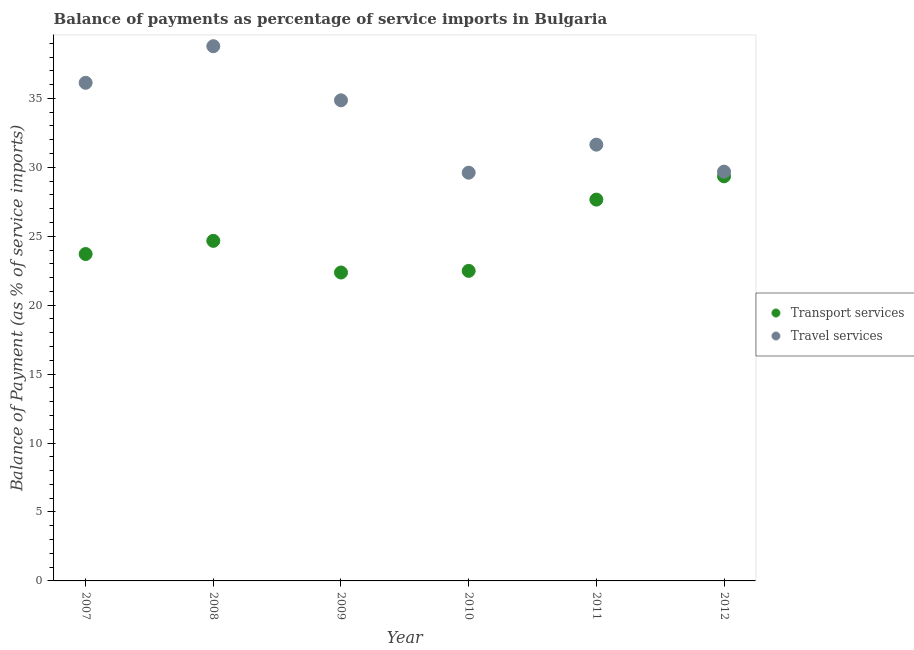How many different coloured dotlines are there?
Your response must be concise. 2. What is the balance of payments of transport services in 2007?
Provide a short and direct response. 23.71. Across all years, what is the maximum balance of payments of transport services?
Provide a short and direct response. 29.35. Across all years, what is the minimum balance of payments of transport services?
Your answer should be very brief. 22.37. What is the total balance of payments of travel services in the graph?
Offer a terse response. 200.73. What is the difference between the balance of payments of travel services in 2007 and that in 2012?
Give a very brief answer. 6.44. What is the difference between the balance of payments of travel services in 2007 and the balance of payments of transport services in 2010?
Give a very brief answer. 13.64. What is the average balance of payments of travel services per year?
Your answer should be compact. 33.45. In the year 2009, what is the difference between the balance of payments of travel services and balance of payments of transport services?
Offer a terse response. 12.49. What is the ratio of the balance of payments of travel services in 2007 to that in 2011?
Your answer should be compact. 1.14. Is the difference between the balance of payments of travel services in 2011 and 2012 greater than the difference between the balance of payments of transport services in 2011 and 2012?
Offer a terse response. Yes. What is the difference between the highest and the second highest balance of payments of transport services?
Your answer should be very brief. 1.69. What is the difference between the highest and the lowest balance of payments of travel services?
Your answer should be compact. 9.18. In how many years, is the balance of payments of transport services greater than the average balance of payments of transport services taken over all years?
Offer a terse response. 2. Does the balance of payments of transport services monotonically increase over the years?
Give a very brief answer. No. Is the balance of payments of travel services strictly greater than the balance of payments of transport services over the years?
Keep it short and to the point. Yes. What is the difference between two consecutive major ticks on the Y-axis?
Keep it short and to the point. 5. Are the values on the major ticks of Y-axis written in scientific E-notation?
Provide a short and direct response. No. Does the graph contain any zero values?
Your answer should be compact. No. Where does the legend appear in the graph?
Make the answer very short. Center right. What is the title of the graph?
Provide a short and direct response. Balance of payments as percentage of service imports in Bulgaria. Does "Female entrants" appear as one of the legend labels in the graph?
Your response must be concise. No. What is the label or title of the X-axis?
Make the answer very short. Year. What is the label or title of the Y-axis?
Ensure brevity in your answer.  Balance of Payment (as % of service imports). What is the Balance of Payment (as % of service imports) in Transport services in 2007?
Provide a succinct answer. 23.71. What is the Balance of Payment (as % of service imports) in Travel services in 2007?
Offer a terse response. 36.13. What is the Balance of Payment (as % of service imports) in Transport services in 2008?
Keep it short and to the point. 24.67. What is the Balance of Payment (as % of service imports) of Travel services in 2008?
Your response must be concise. 38.79. What is the Balance of Payment (as % of service imports) in Transport services in 2009?
Provide a succinct answer. 22.37. What is the Balance of Payment (as % of service imports) in Travel services in 2009?
Ensure brevity in your answer.  34.86. What is the Balance of Payment (as % of service imports) of Transport services in 2010?
Provide a succinct answer. 22.49. What is the Balance of Payment (as % of service imports) of Travel services in 2010?
Offer a terse response. 29.61. What is the Balance of Payment (as % of service imports) in Transport services in 2011?
Make the answer very short. 27.66. What is the Balance of Payment (as % of service imports) in Travel services in 2011?
Keep it short and to the point. 31.65. What is the Balance of Payment (as % of service imports) in Transport services in 2012?
Keep it short and to the point. 29.35. What is the Balance of Payment (as % of service imports) of Travel services in 2012?
Offer a terse response. 29.69. Across all years, what is the maximum Balance of Payment (as % of service imports) in Transport services?
Your answer should be very brief. 29.35. Across all years, what is the maximum Balance of Payment (as % of service imports) of Travel services?
Offer a terse response. 38.79. Across all years, what is the minimum Balance of Payment (as % of service imports) in Transport services?
Your response must be concise. 22.37. Across all years, what is the minimum Balance of Payment (as % of service imports) in Travel services?
Provide a succinct answer. 29.61. What is the total Balance of Payment (as % of service imports) of Transport services in the graph?
Give a very brief answer. 150.25. What is the total Balance of Payment (as % of service imports) of Travel services in the graph?
Offer a terse response. 200.73. What is the difference between the Balance of Payment (as % of service imports) of Transport services in 2007 and that in 2008?
Offer a very short reply. -0.96. What is the difference between the Balance of Payment (as % of service imports) in Travel services in 2007 and that in 2008?
Ensure brevity in your answer.  -2.66. What is the difference between the Balance of Payment (as % of service imports) of Transport services in 2007 and that in 2009?
Make the answer very short. 1.34. What is the difference between the Balance of Payment (as % of service imports) of Travel services in 2007 and that in 2009?
Your response must be concise. 1.27. What is the difference between the Balance of Payment (as % of service imports) of Transport services in 2007 and that in 2010?
Keep it short and to the point. 1.22. What is the difference between the Balance of Payment (as % of service imports) in Travel services in 2007 and that in 2010?
Provide a short and direct response. 6.52. What is the difference between the Balance of Payment (as % of service imports) of Transport services in 2007 and that in 2011?
Your response must be concise. -3.95. What is the difference between the Balance of Payment (as % of service imports) of Travel services in 2007 and that in 2011?
Provide a short and direct response. 4.49. What is the difference between the Balance of Payment (as % of service imports) in Transport services in 2007 and that in 2012?
Ensure brevity in your answer.  -5.64. What is the difference between the Balance of Payment (as % of service imports) of Travel services in 2007 and that in 2012?
Your answer should be compact. 6.44. What is the difference between the Balance of Payment (as % of service imports) of Transport services in 2008 and that in 2009?
Your answer should be very brief. 2.3. What is the difference between the Balance of Payment (as % of service imports) in Travel services in 2008 and that in 2009?
Make the answer very short. 3.93. What is the difference between the Balance of Payment (as % of service imports) of Transport services in 2008 and that in 2010?
Offer a very short reply. 2.18. What is the difference between the Balance of Payment (as % of service imports) of Travel services in 2008 and that in 2010?
Keep it short and to the point. 9.18. What is the difference between the Balance of Payment (as % of service imports) in Transport services in 2008 and that in 2011?
Offer a terse response. -2.99. What is the difference between the Balance of Payment (as % of service imports) in Travel services in 2008 and that in 2011?
Your response must be concise. 7.14. What is the difference between the Balance of Payment (as % of service imports) in Transport services in 2008 and that in 2012?
Provide a succinct answer. -4.68. What is the difference between the Balance of Payment (as % of service imports) of Travel services in 2008 and that in 2012?
Give a very brief answer. 9.1. What is the difference between the Balance of Payment (as % of service imports) of Transport services in 2009 and that in 2010?
Ensure brevity in your answer.  -0.12. What is the difference between the Balance of Payment (as % of service imports) in Travel services in 2009 and that in 2010?
Keep it short and to the point. 5.25. What is the difference between the Balance of Payment (as % of service imports) of Transport services in 2009 and that in 2011?
Make the answer very short. -5.29. What is the difference between the Balance of Payment (as % of service imports) in Travel services in 2009 and that in 2011?
Your answer should be very brief. 3.22. What is the difference between the Balance of Payment (as % of service imports) of Transport services in 2009 and that in 2012?
Provide a succinct answer. -6.98. What is the difference between the Balance of Payment (as % of service imports) of Travel services in 2009 and that in 2012?
Your answer should be very brief. 5.17. What is the difference between the Balance of Payment (as % of service imports) in Transport services in 2010 and that in 2011?
Your answer should be compact. -5.17. What is the difference between the Balance of Payment (as % of service imports) in Travel services in 2010 and that in 2011?
Provide a succinct answer. -2.03. What is the difference between the Balance of Payment (as % of service imports) of Transport services in 2010 and that in 2012?
Offer a very short reply. -6.86. What is the difference between the Balance of Payment (as % of service imports) of Travel services in 2010 and that in 2012?
Keep it short and to the point. -0.08. What is the difference between the Balance of Payment (as % of service imports) in Transport services in 2011 and that in 2012?
Keep it short and to the point. -1.69. What is the difference between the Balance of Payment (as % of service imports) of Travel services in 2011 and that in 2012?
Provide a succinct answer. 1.96. What is the difference between the Balance of Payment (as % of service imports) in Transport services in 2007 and the Balance of Payment (as % of service imports) in Travel services in 2008?
Provide a short and direct response. -15.08. What is the difference between the Balance of Payment (as % of service imports) in Transport services in 2007 and the Balance of Payment (as % of service imports) in Travel services in 2009?
Give a very brief answer. -11.15. What is the difference between the Balance of Payment (as % of service imports) in Transport services in 2007 and the Balance of Payment (as % of service imports) in Travel services in 2010?
Offer a terse response. -5.9. What is the difference between the Balance of Payment (as % of service imports) in Transport services in 2007 and the Balance of Payment (as % of service imports) in Travel services in 2011?
Offer a terse response. -7.93. What is the difference between the Balance of Payment (as % of service imports) of Transport services in 2007 and the Balance of Payment (as % of service imports) of Travel services in 2012?
Provide a succinct answer. -5.98. What is the difference between the Balance of Payment (as % of service imports) in Transport services in 2008 and the Balance of Payment (as % of service imports) in Travel services in 2009?
Keep it short and to the point. -10.19. What is the difference between the Balance of Payment (as % of service imports) of Transport services in 2008 and the Balance of Payment (as % of service imports) of Travel services in 2010?
Give a very brief answer. -4.94. What is the difference between the Balance of Payment (as % of service imports) of Transport services in 2008 and the Balance of Payment (as % of service imports) of Travel services in 2011?
Ensure brevity in your answer.  -6.98. What is the difference between the Balance of Payment (as % of service imports) of Transport services in 2008 and the Balance of Payment (as % of service imports) of Travel services in 2012?
Provide a succinct answer. -5.02. What is the difference between the Balance of Payment (as % of service imports) of Transport services in 2009 and the Balance of Payment (as % of service imports) of Travel services in 2010?
Your response must be concise. -7.24. What is the difference between the Balance of Payment (as % of service imports) in Transport services in 2009 and the Balance of Payment (as % of service imports) in Travel services in 2011?
Provide a short and direct response. -9.27. What is the difference between the Balance of Payment (as % of service imports) of Transport services in 2009 and the Balance of Payment (as % of service imports) of Travel services in 2012?
Ensure brevity in your answer.  -7.32. What is the difference between the Balance of Payment (as % of service imports) of Transport services in 2010 and the Balance of Payment (as % of service imports) of Travel services in 2011?
Give a very brief answer. -9.15. What is the difference between the Balance of Payment (as % of service imports) in Transport services in 2010 and the Balance of Payment (as % of service imports) in Travel services in 2012?
Make the answer very short. -7.2. What is the difference between the Balance of Payment (as % of service imports) of Transport services in 2011 and the Balance of Payment (as % of service imports) of Travel services in 2012?
Your answer should be compact. -2.03. What is the average Balance of Payment (as % of service imports) in Transport services per year?
Give a very brief answer. 25.04. What is the average Balance of Payment (as % of service imports) of Travel services per year?
Make the answer very short. 33.45. In the year 2007, what is the difference between the Balance of Payment (as % of service imports) of Transport services and Balance of Payment (as % of service imports) of Travel services?
Ensure brevity in your answer.  -12.42. In the year 2008, what is the difference between the Balance of Payment (as % of service imports) in Transport services and Balance of Payment (as % of service imports) in Travel services?
Your answer should be compact. -14.12. In the year 2009, what is the difference between the Balance of Payment (as % of service imports) of Transport services and Balance of Payment (as % of service imports) of Travel services?
Ensure brevity in your answer.  -12.49. In the year 2010, what is the difference between the Balance of Payment (as % of service imports) in Transport services and Balance of Payment (as % of service imports) in Travel services?
Keep it short and to the point. -7.12. In the year 2011, what is the difference between the Balance of Payment (as % of service imports) of Transport services and Balance of Payment (as % of service imports) of Travel services?
Your answer should be compact. -3.99. In the year 2012, what is the difference between the Balance of Payment (as % of service imports) of Transport services and Balance of Payment (as % of service imports) of Travel services?
Offer a very short reply. -0.34. What is the ratio of the Balance of Payment (as % of service imports) in Transport services in 2007 to that in 2008?
Offer a very short reply. 0.96. What is the ratio of the Balance of Payment (as % of service imports) of Travel services in 2007 to that in 2008?
Keep it short and to the point. 0.93. What is the ratio of the Balance of Payment (as % of service imports) in Transport services in 2007 to that in 2009?
Your answer should be compact. 1.06. What is the ratio of the Balance of Payment (as % of service imports) of Travel services in 2007 to that in 2009?
Your answer should be compact. 1.04. What is the ratio of the Balance of Payment (as % of service imports) of Transport services in 2007 to that in 2010?
Provide a succinct answer. 1.05. What is the ratio of the Balance of Payment (as % of service imports) of Travel services in 2007 to that in 2010?
Keep it short and to the point. 1.22. What is the ratio of the Balance of Payment (as % of service imports) in Transport services in 2007 to that in 2011?
Make the answer very short. 0.86. What is the ratio of the Balance of Payment (as % of service imports) of Travel services in 2007 to that in 2011?
Provide a succinct answer. 1.14. What is the ratio of the Balance of Payment (as % of service imports) in Transport services in 2007 to that in 2012?
Provide a succinct answer. 0.81. What is the ratio of the Balance of Payment (as % of service imports) of Travel services in 2007 to that in 2012?
Provide a short and direct response. 1.22. What is the ratio of the Balance of Payment (as % of service imports) in Transport services in 2008 to that in 2009?
Make the answer very short. 1.1. What is the ratio of the Balance of Payment (as % of service imports) in Travel services in 2008 to that in 2009?
Ensure brevity in your answer.  1.11. What is the ratio of the Balance of Payment (as % of service imports) in Transport services in 2008 to that in 2010?
Your answer should be very brief. 1.1. What is the ratio of the Balance of Payment (as % of service imports) of Travel services in 2008 to that in 2010?
Keep it short and to the point. 1.31. What is the ratio of the Balance of Payment (as % of service imports) in Transport services in 2008 to that in 2011?
Your answer should be compact. 0.89. What is the ratio of the Balance of Payment (as % of service imports) in Travel services in 2008 to that in 2011?
Provide a short and direct response. 1.23. What is the ratio of the Balance of Payment (as % of service imports) of Transport services in 2008 to that in 2012?
Keep it short and to the point. 0.84. What is the ratio of the Balance of Payment (as % of service imports) in Travel services in 2008 to that in 2012?
Your answer should be very brief. 1.31. What is the ratio of the Balance of Payment (as % of service imports) in Transport services in 2009 to that in 2010?
Provide a short and direct response. 0.99. What is the ratio of the Balance of Payment (as % of service imports) of Travel services in 2009 to that in 2010?
Offer a terse response. 1.18. What is the ratio of the Balance of Payment (as % of service imports) of Transport services in 2009 to that in 2011?
Offer a terse response. 0.81. What is the ratio of the Balance of Payment (as % of service imports) of Travel services in 2009 to that in 2011?
Keep it short and to the point. 1.1. What is the ratio of the Balance of Payment (as % of service imports) of Transport services in 2009 to that in 2012?
Your response must be concise. 0.76. What is the ratio of the Balance of Payment (as % of service imports) of Travel services in 2009 to that in 2012?
Your response must be concise. 1.17. What is the ratio of the Balance of Payment (as % of service imports) of Transport services in 2010 to that in 2011?
Give a very brief answer. 0.81. What is the ratio of the Balance of Payment (as % of service imports) of Travel services in 2010 to that in 2011?
Provide a short and direct response. 0.94. What is the ratio of the Balance of Payment (as % of service imports) of Transport services in 2010 to that in 2012?
Give a very brief answer. 0.77. What is the ratio of the Balance of Payment (as % of service imports) of Travel services in 2010 to that in 2012?
Your answer should be very brief. 1. What is the ratio of the Balance of Payment (as % of service imports) of Transport services in 2011 to that in 2012?
Offer a terse response. 0.94. What is the ratio of the Balance of Payment (as % of service imports) in Travel services in 2011 to that in 2012?
Offer a very short reply. 1.07. What is the difference between the highest and the second highest Balance of Payment (as % of service imports) of Transport services?
Provide a succinct answer. 1.69. What is the difference between the highest and the second highest Balance of Payment (as % of service imports) in Travel services?
Offer a terse response. 2.66. What is the difference between the highest and the lowest Balance of Payment (as % of service imports) in Transport services?
Give a very brief answer. 6.98. What is the difference between the highest and the lowest Balance of Payment (as % of service imports) of Travel services?
Offer a terse response. 9.18. 